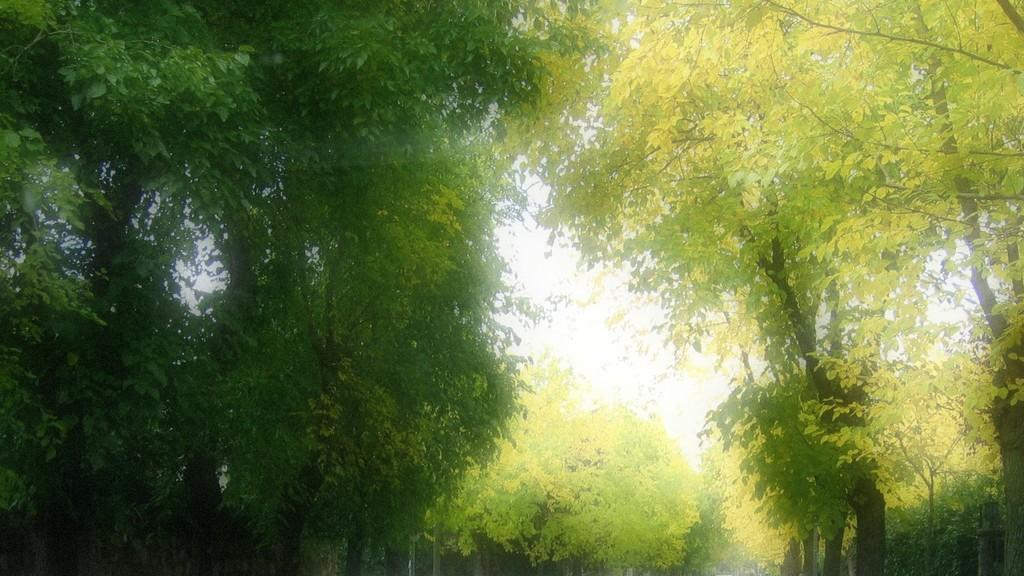What type of vegetation is present in the image? There are trees in the image. What features can be observed on the trees? The trees have branches and leaves. What is the color of the leaves on the trees? The leaves are green in color. How many cakes are hanging from the branches of the trees in the image? There are no cakes present in the image; the trees have leaves, not cakes. 